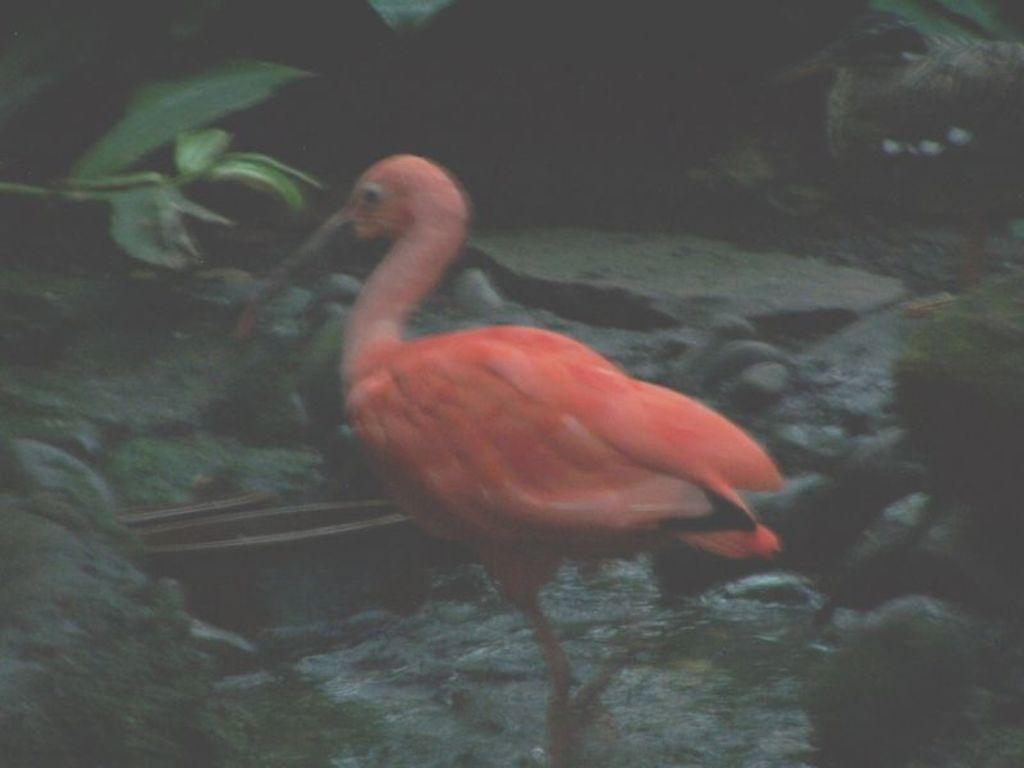What type of objects can be seen in the image? There are rocks in the image. What color is the crane in the image? The crane in the image is orange-colored. Where can the honey be found in the image? There is no honey present in the image. What type of vehicles are visible in the image? There are no vehicles visible in the image, only rocks and a crane. 